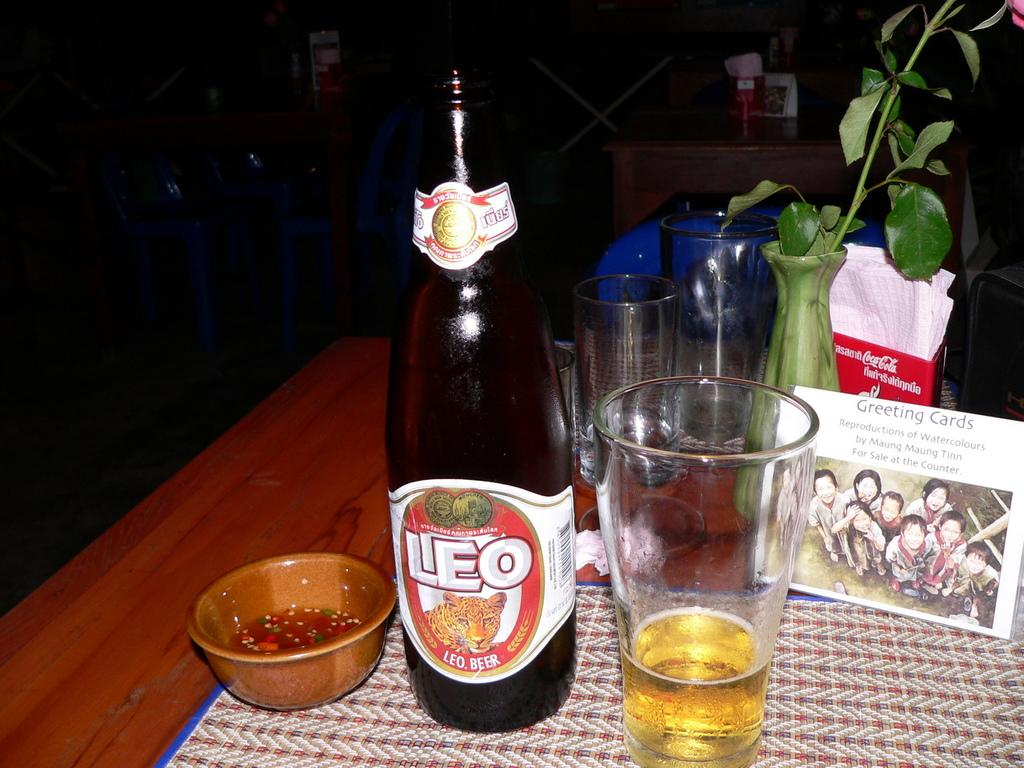<image>
Summarize the visual content of the image. LEO Beer Bottle with a small cup and greeting cards on a table. 